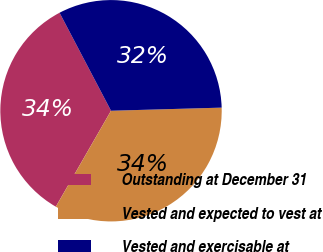<chart> <loc_0><loc_0><loc_500><loc_500><pie_chart><fcel>Outstanding at December 31<fcel>Vested and expected to vest at<fcel>Vested and exercisable at<nl><fcel>34.0%<fcel>33.76%<fcel>32.25%<nl></chart> 